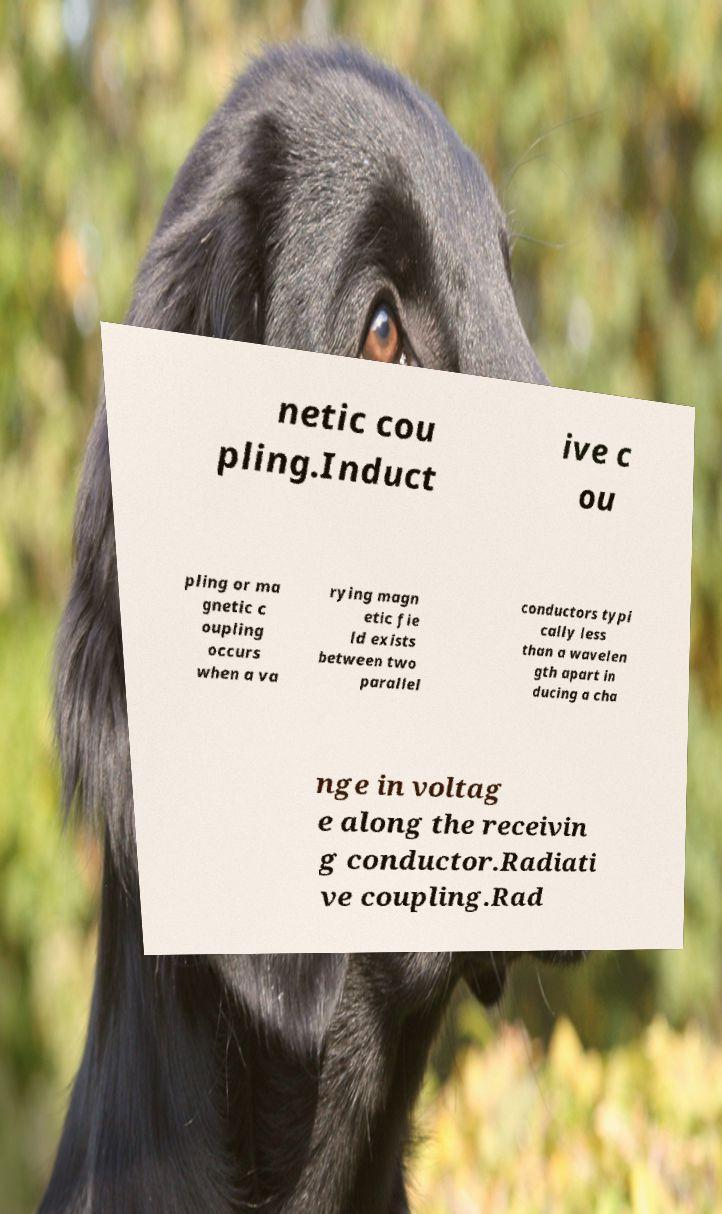Could you assist in decoding the text presented in this image and type it out clearly? netic cou pling.Induct ive c ou pling or ma gnetic c oupling occurs when a va rying magn etic fie ld exists between two parallel conductors typi cally less than a wavelen gth apart in ducing a cha nge in voltag e along the receivin g conductor.Radiati ve coupling.Rad 